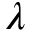<formula> <loc_0><loc_0><loc_500><loc_500>\lambda</formula> 